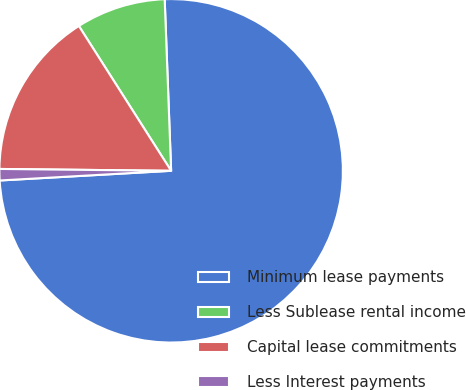Convert chart to OTSL. <chart><loc_0><loc_0><loc_500><loc_500><pie_chart><fcel>Minimum lease payments<fcel>Less Sublease rental income<fcel>Capital lease commitments<fcel>Less Interest payments<nl><fcel>74.7%<fcel>8.43%<fcel>15.8%<fcel>1.07%<nl></chart> 